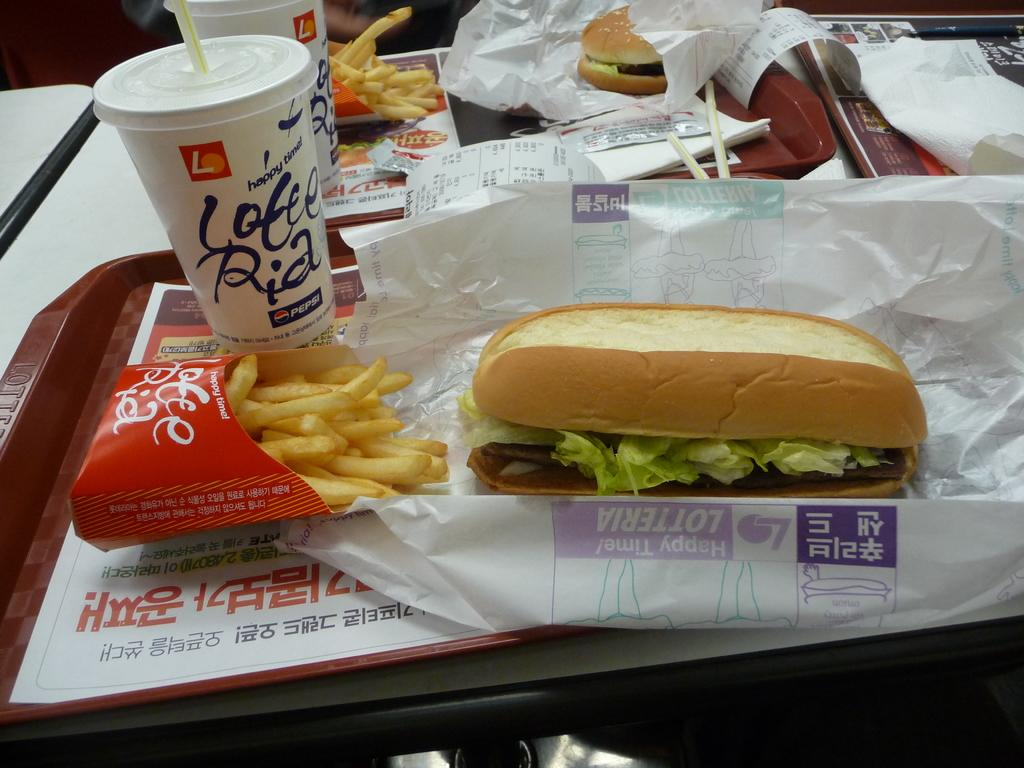What is the main object in the center of the image? There is a table in the center of the image. What items can be seen on the table? On the table, there are plates, tissue papers, cool drink glasses, hot dogs, sauce packets, a bill paper, and French fries. Are there any other unspecified objects on the table? Yes, there are other unspecified objects on the table. Can you observe the moon in the image? No, the moon is not present in the image. What type of rub is being used to clean the table in the image? There is no rub visible in the image; only tissue papers are present for cleaning or wiping. 